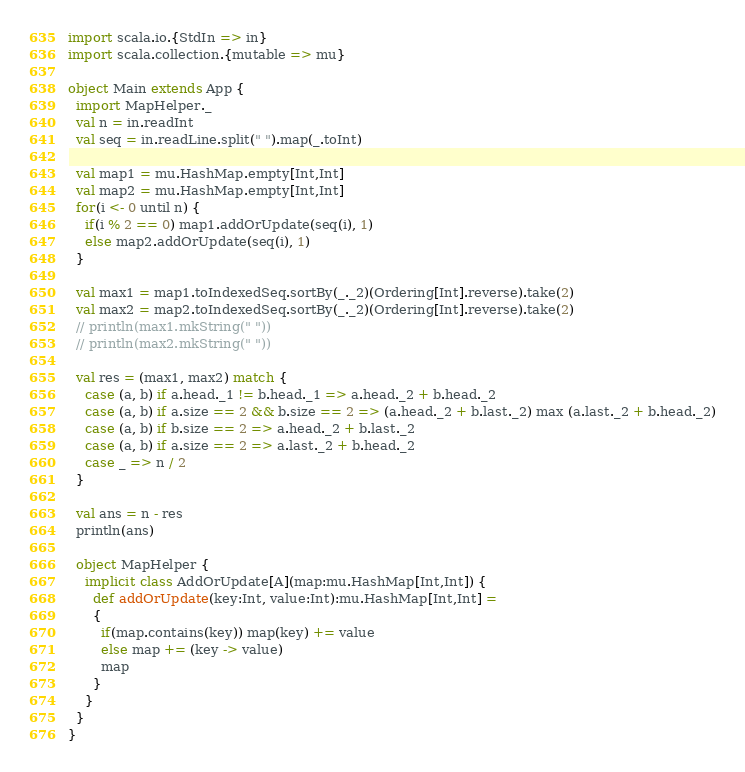<code> <loc_0><loc_0><loc_500><loc_500><_Scala_>import scala.io.{StdIn => in}
import scala.collection.{mutable => mu}

object Main extends App {
  import MapHelper._
  val n = in.readInt
  val seq = in.readLine.split(" ").map(_.toInt)

  val map1 = mu.HashMap.empty[Int,Int]
  val map2 = mu.HashMap.empty[Int,Int]
  for(i <- 0 until n) {
    if(i % 2 == 0) map1.addOrUpdate(seq(i), 1)
    else map2.addOrUpdate(seq(i), 1)
  }

  val max1 = map1.toIndexedSeq.sortBy(_._2)(Ordering[Int].reverse).take(2)
  val max2 = map2.toIndexedSeq.sortBy(_._2)(Ordering[Int].reverse).take(2)
  // println(max1.mkString(" "))
  // println(max2.mkString(" "))

  val res = (max1, max2) match {
    case (a, b) if a.head._1 != b.head._1 => a.head._2 + b.head._2
    case (a, b) if a.size == 2 && b.size == 2 => (a.head._2 + b.last._2) max (a.last._2 + b.head._2)
    case (a, b) if b.size == 2 => a.head._2 + b.last._2
    case (a, b) if a.size == 2 => a.last._2 + b.head._2
    case _ => n / 2
  }

  val ans = n - res
  println(ans)

  object MapHelper {
    implicit class AddOrUpdate[A](map:mu.HashMap[Int,Int]) {
      def addOrUpdate(key:Int, value:Int):mu.HashMap[Int,Int] =
      {
        if(map.contains(key)) map(key) += value
        else map += (key -> value)
        map
      }
    }
  }
}</code> 